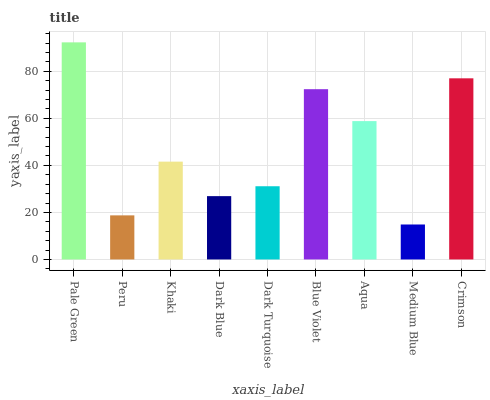Is Medium Blue the minimum?
Answer yes or no. Yes. Is Pale Green the maximum?
Answer yes or no. Yes. Is Peru the minimum?
Answer yes or no. No. Is Peru the maximum?
Answer yes or no. No. Is Pale Green greater than Peru?
Answer yes or no. Yes. Is Peru less than Pale Green?
Answer yes or no. Yes. Is Peru greater than Pale Green?
Answer yes or no. No. Is Pale Green less than Peru?
Answer yes or no. No. Is Khaki the high median?
Answer yes or no. Yes. Is Khaki the low median?
Answer yes or no. Yes. Is Dark Turquoise the high median?
Answer yes or no. No. Is Blue Violet the low median?
Answer yes or no. No. 